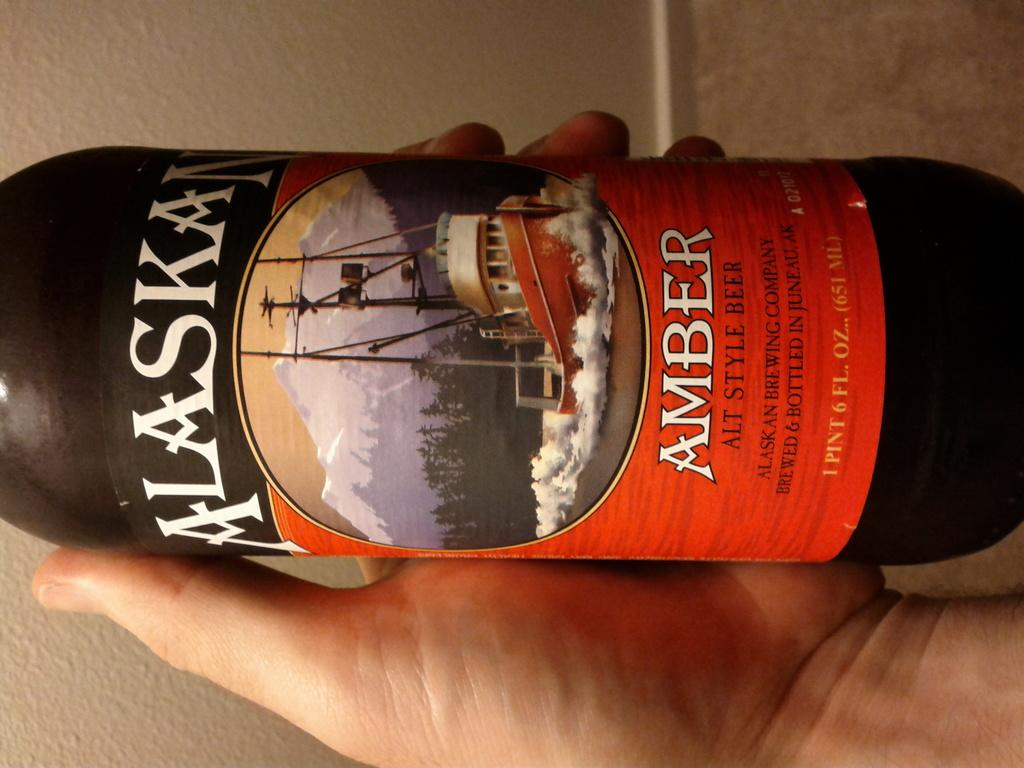<image>
Present a compact description of the photo's key features. The beer shown with a snowy boat picture if from Alaska. 